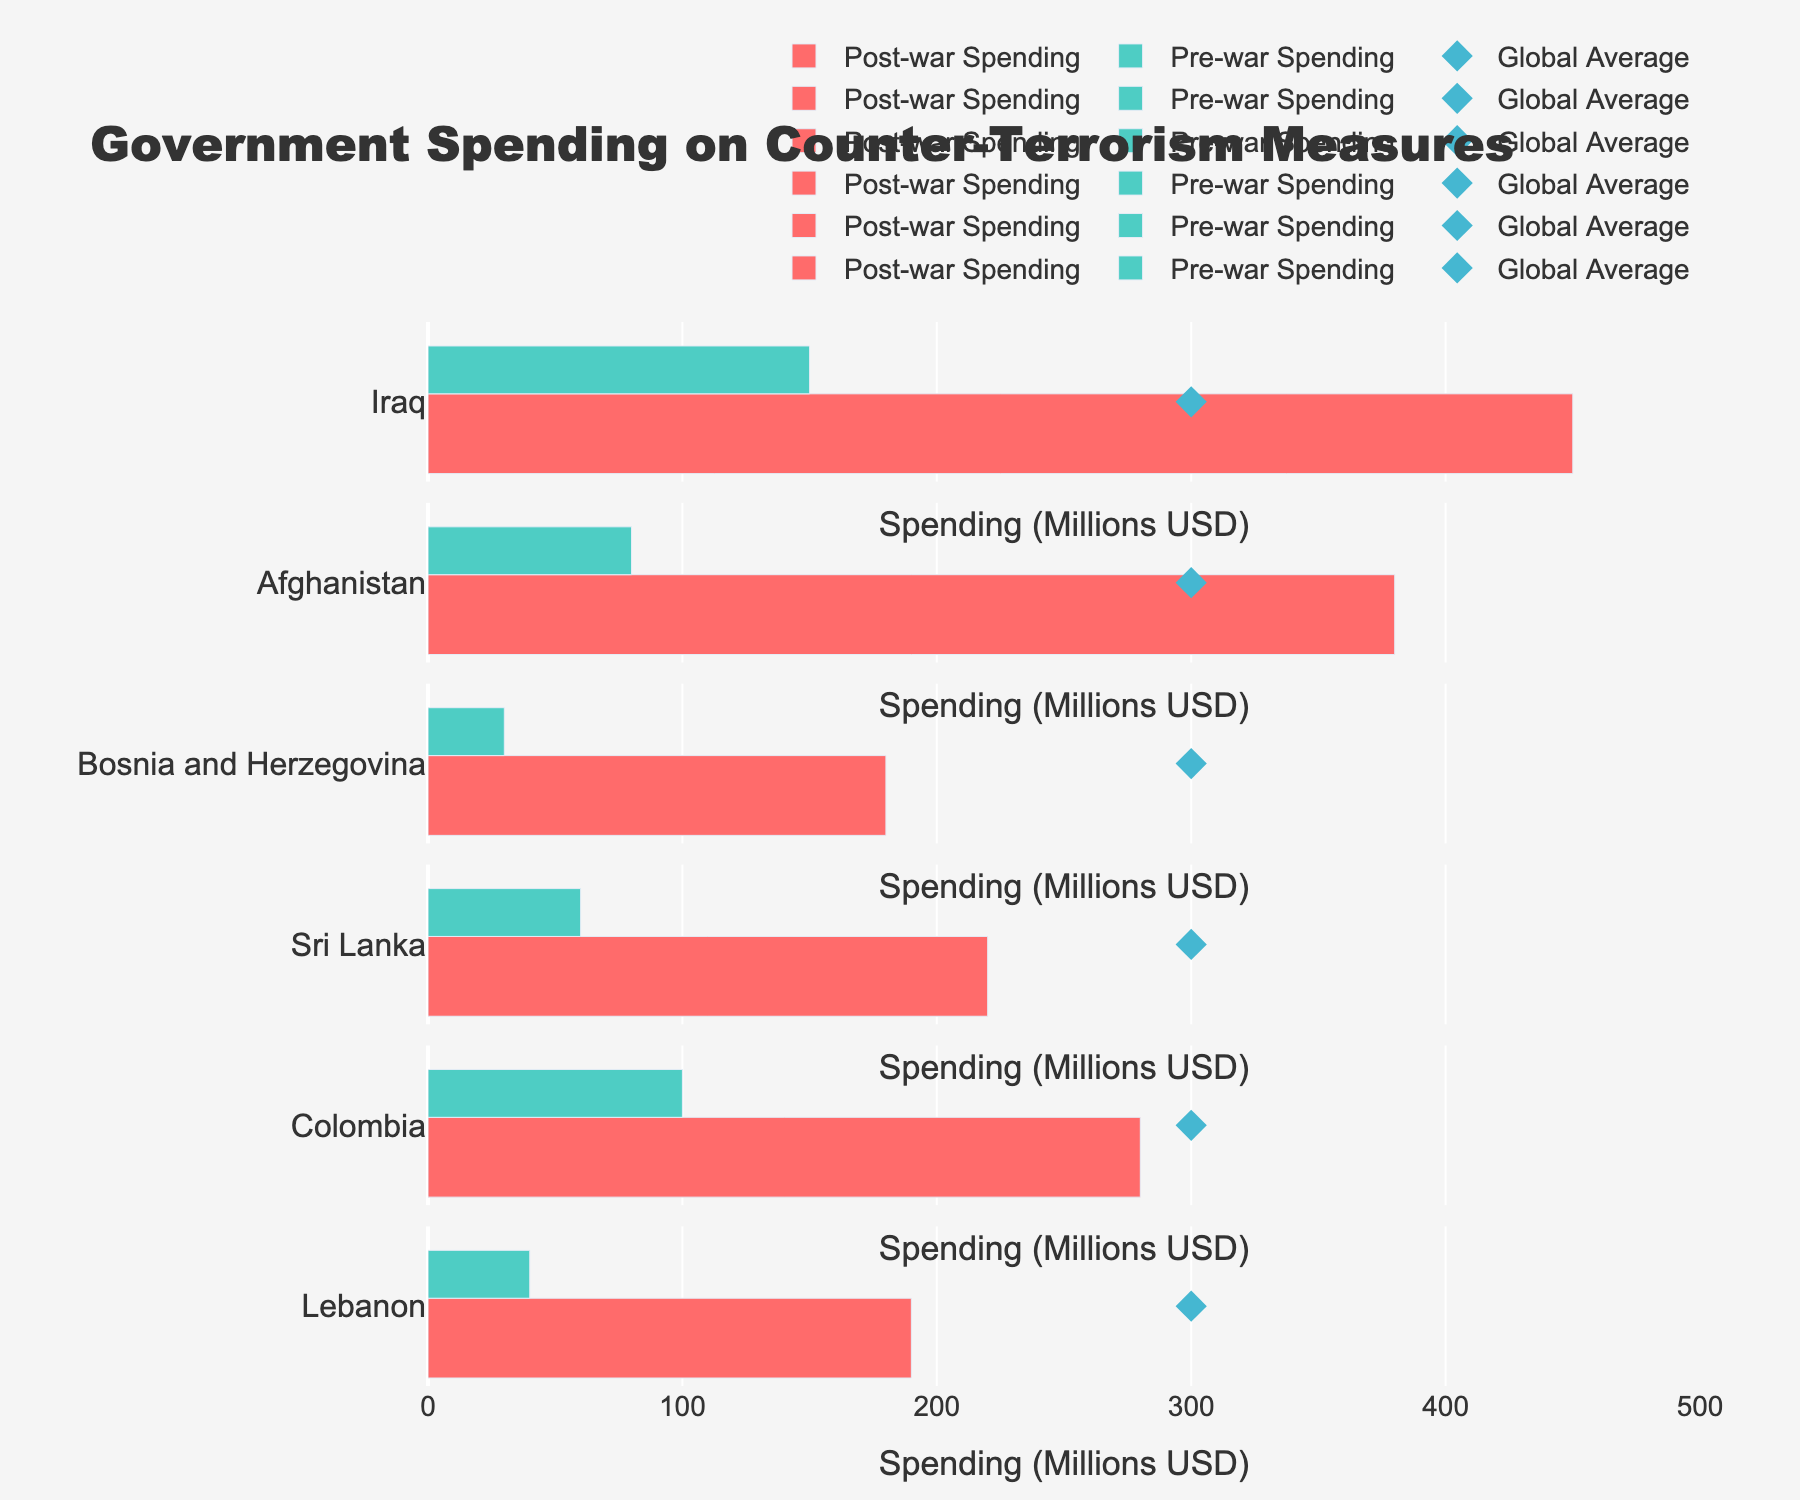What's the title of the figure? The title is usually prominent and located at the top of the figure.
Answer: "Government Spending on Counter-Terrorism Measures" How much did Afghanistan spend on counter-terrorism post-war? Look at Afghanistan's bar representing "Post-war Spending".
Answer: 380 million USD Which country has the highest post-war spending on counter-terrorism measures? Identify the longest "Post-war Spending" bar.
Answer: Iraq How does the post-war spending of Sri Lanka compare to the global average? Compare Sri Lanka's "Post-war Spending" bar with the "Global Average" marker.
Answer: Below the global average What is the difference between pre-war and post-war spending in Bosnia and Herzegovina? Subtract the "Pre-war Spending" value from the "Post-war Spending" value for Bosnia and Herzegovina.  180 - 30
Answer: 150 million USD Which country increased their spending by the largest amount from pre-war to post-war? Calculate the difference between post-war and pre-war spending for each country and find the maximum.
Answer: Iraq (300 million USD) How many countries have post-war spending below the global average? Count the number of post-war bars shorter than the "Global Average" marker: Iraq, Afghanistan, Bosnia and Herzegovina, Sri Lanka, Colombia, Lebanon.
Answer: 6 countries What is the total pre-war spending on counter-terrorism measures by all listed countries? Sum the "Pre-war Spending" values: 150 + 80 + 30 + 60 + 100 + 40.
Answer: 460 million USD Which country's pre-war spending is closest to the global average? Identify the "Pre-war Spending" bar closest to the "Global Average" marker.
Answer: None (All are significantly below the global average) What can you infer about the trend in spending on counter-terrorism from pre-war to post-war in these countries? Generally, all countries have increased their spending post-war, indicating a heightened focus on counter-terrorism after conflicts.
Answer: Increased in all listed countries 